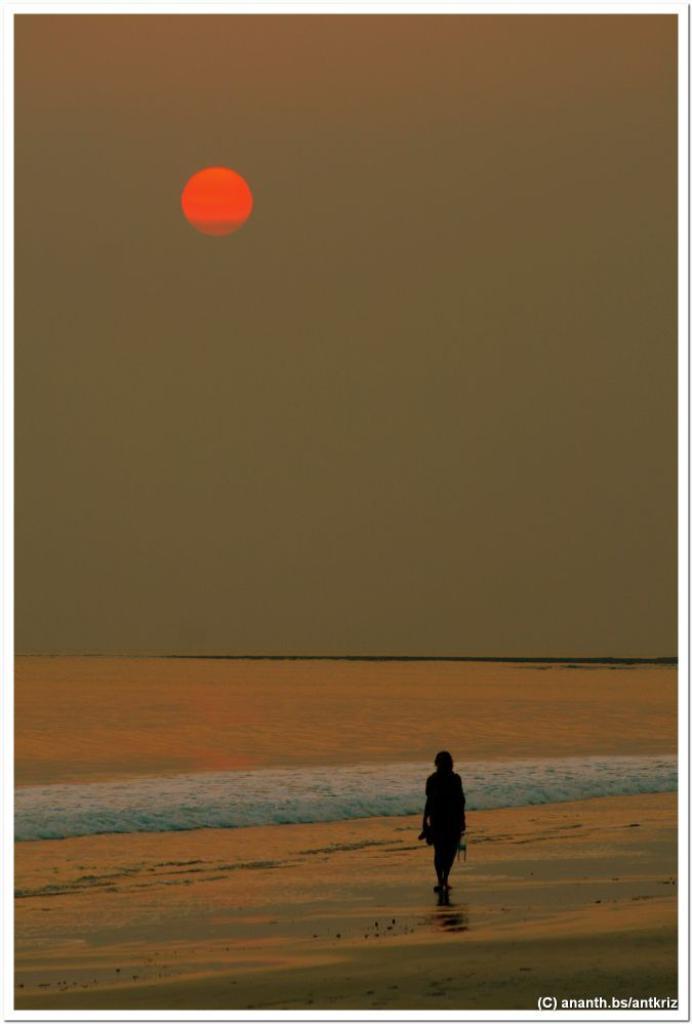Please provide a concise description of this image. In this image we can see a photo with border and there is a person and we can see the ocean and at the top we can see the sun in the sky. 